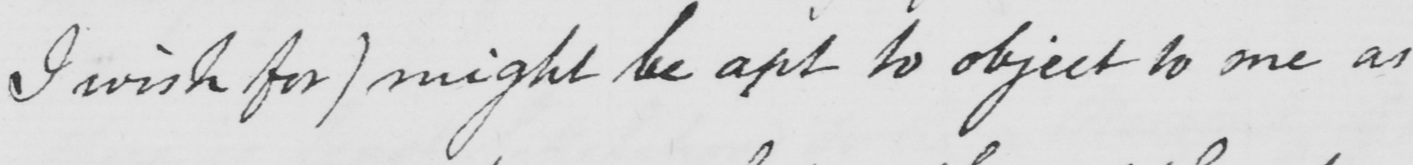What text is written in this handwritten line? I wish for ) might be apt to object to me as 